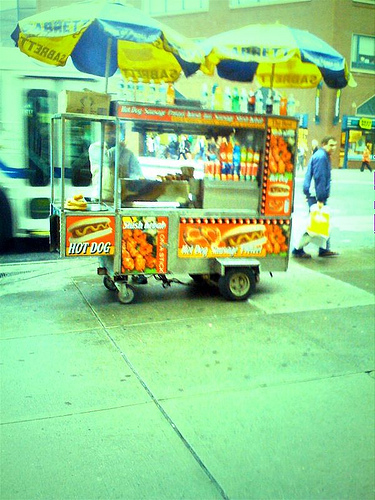Identify the text displayed in this image. HOT DOG 